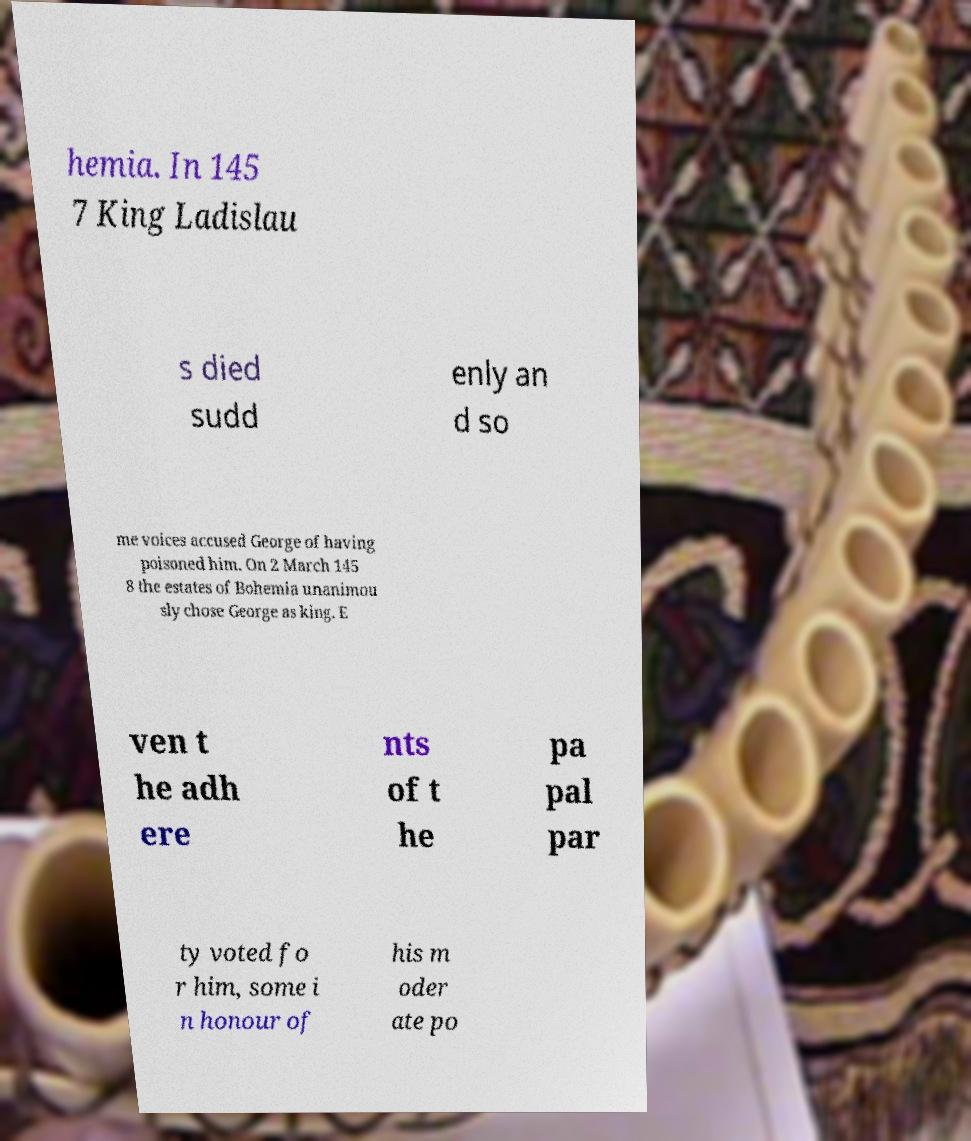Could you extract and type out the text from this image? hemia. In 145 7 King Ladislau s died sudd enly an d so me voices accused George of having poisoned him. On 2 March 145 8 the estates of Bohemia unanimou sly chose George as king. E ven t he adh ere nts of t he pa pal par ty voted fo r him, some i n honour of his m oder ate po 